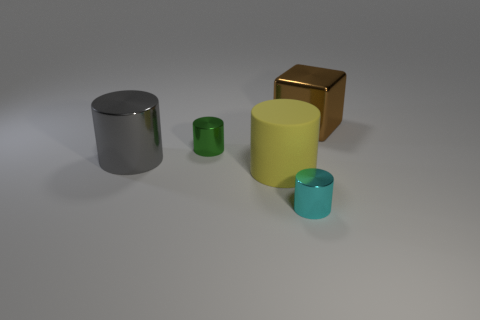There is a big metallic object in front of the large brown metallic block; does it have the same shape as the small cyan metal thing?
Give a very brief answer. Yes. Is the number of objects that are to the left of the gray metal thing greater than the number of brown metal things?
Keep it short and to the point. No. There is a shiny cylinder that is the same size as the brown metal object; what is its color?
Give a very brief answer. Gray. What number of things are either tiny metallic objects that are in front of the large gray metal cylinder or gray cylinders?
Your answer should be very brief. 2. What material is the tiny object that is behind the tiny cylinder on the right side of the yellow rubber object?
Your answer should be compact. Metal. Are there any red objects that have the same material as the large brown thing?
Ensure brevity in your answer.  No. Is there a big gray shiny thing in front of the large thing in front of the large gray metal object?
Your answer should be very brief. No. There is a small object that is left of the tiny cyan cylinder; what is its material?
Keep it short and to the point. Metal. Do the small cyan shiny thing and the small green metal thing have the same shape?
Give a very brief answer. Yes. What is the color of the tiny shiny thing that is behind the small cyan metallic cylinder to the right of the large cylinder that is behind the rubber thing?
Offer a very short reply. Green. 